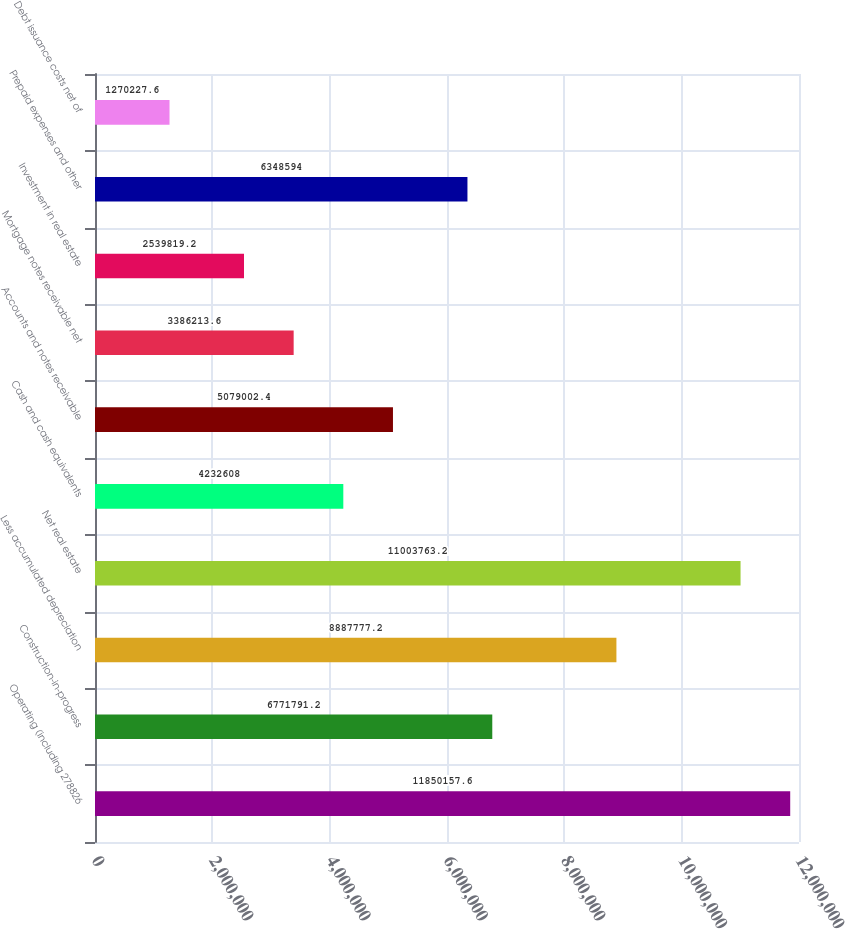<chart> <loc_0><loc_0><loc_500><loc_500><bar_chart><fcel>Operating (including 278826<fcel>Construction-in-progress<fcel>Less accumulated depreciation<fcel>Net real estate<fcel>Cash and cash equivalents<fcel>Accounts and notes receivable<fcel>Mortgage notes receivable net<fcel>Investment in real estate<fcel>Prepaid expenses and other<fcel>Debt issuance costs net of<nl><fcel>1.18502e+07<fcel>6.77179e+06<fcel>8.88778e+06<fcel>1.10038e+07<fcel>4.23261e+06<fcel>5.079e+06<fcel>3.38621e+06<fcel>2.53982e+06<fcel>6.34859e+06<fcel>1.27023e+06<nl></chart> 